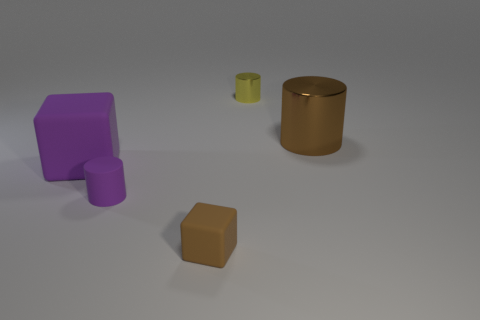What material is the thing that is the same color as the large cylinder?
Make the answer very short. Rubber. What color is the rubber thing that is the same shape as the yellow shiny thing?
Offer a very short reply. Purple. How big is the thing that is both in front of the brown shiny cylinder and behind the small purple cylinder?
Make the answer very short. Large. There is a matte cube that is left of the small rubber object behind the small brown block; how many things are in front of it?
Keep it short and to the point. 2. How many tiny objects are either yellow metallic cylinders or brown rubber cubes?
Provide a succinct answer. 2. Is the material of the brown object in front of the purple cylinder the same as the big cube?
Offer a very short reply. Yes. The cylinder to the left of the brown thing that is in front of the metal cylinder right of the tiny shiny thing is made of what material?
Ensure brevity in your answer.  Rubber. Is there anything else that is the same size as the brown rubber block?
Your answer should be very brief. Yes. How many metallic objects are either small yellow cylinders or tiny purple cylinders?
Your response must be concise. 1. Is there a block?
Offer a terse response. Yes. 